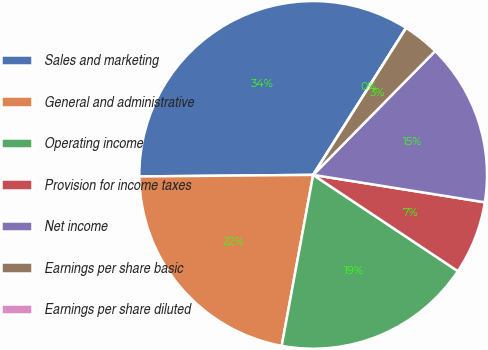<chart> <loc_0><loc_0><loc_500><loc_500><pie_chart><fcel>Sales and marketing<fcel>General and administrative<fcel>Operating income<fcel>Provision for income taxes<fcel>Net income<fcel>Earnings per share basic<fcel>Earnings per share diluted<nl><fcel>34.11%<fcel>21.96%<fcel>18.55%<fcel>6.82%<fcel>15.14%<fcel>3.41%<fcel>0.0%<nl></chart> 